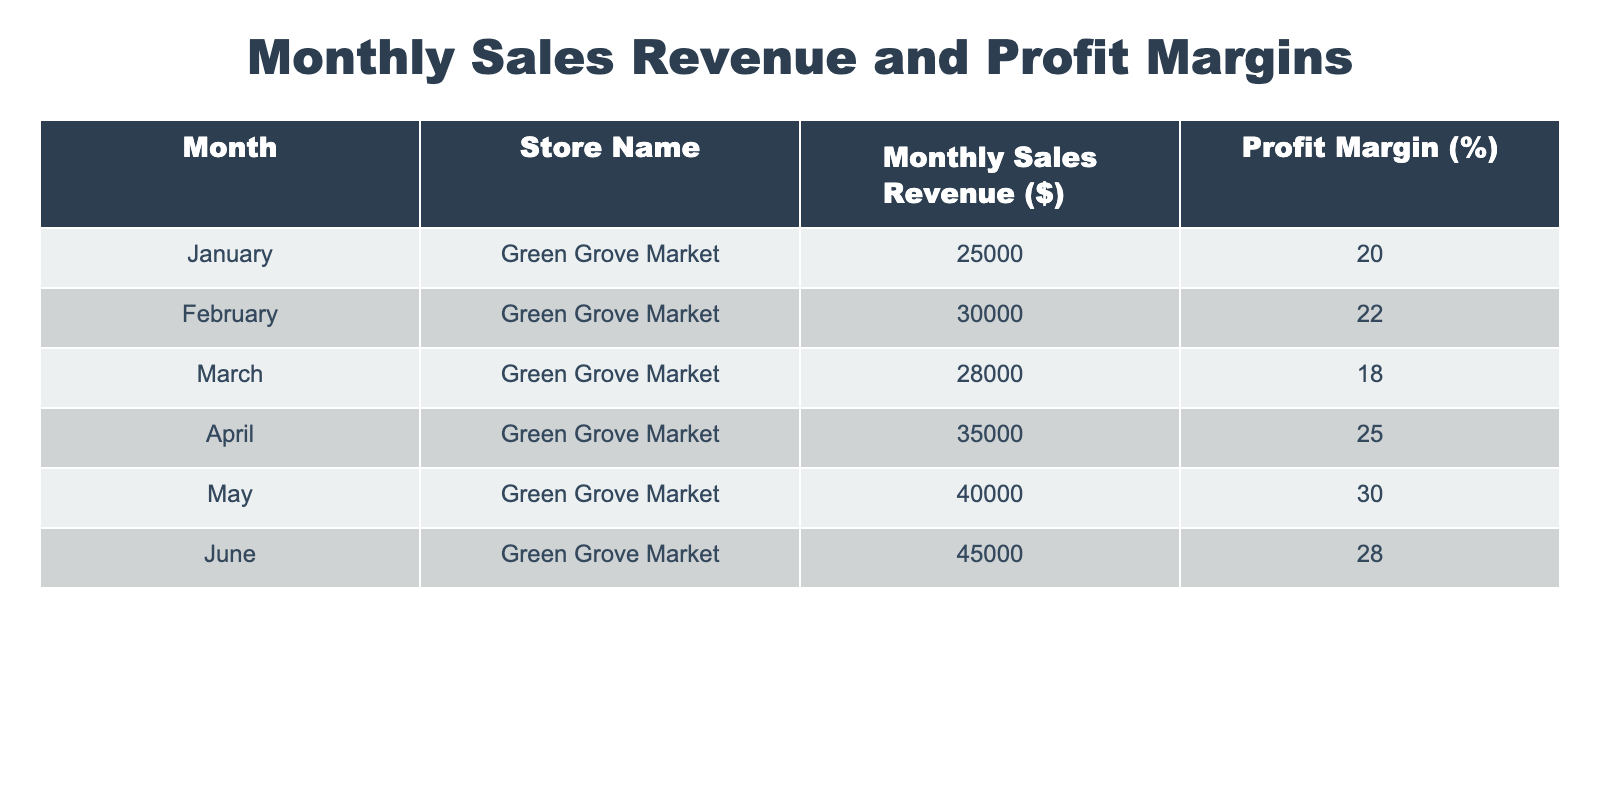What was the monthly sales revenue in June? The table directly lists the monthly sales revenue for each month. Specifically, for June, the value given in the table is 45000.
Answer: 45000 What is the profit margin in April? The table indicates that the profit margin for April is 25%. This is a straightforward retrieval from the table.
Answer: 25% Which month had the highest profit margin, and what was it? By examining the profit margins for each month listed in the table, April has the highest at 25%. This requires comparing the values.
Answer: April, 25% What is the average monthly sales revenue over the six months? To calculate the average monthly sales revenue, add all the monthly sales revenue values: 25000 + 30000 + 28000 + 35000 + 40000 + 45000 = 203000. Then, divide by the number of months (6): 203000/6 = approximately 33833.33.
Answer: 33833.33 Is the profit margin in May higher than in March? The table shows that the profit margin in May is 30% while in March it is 18%. Since 30% > 18%, the answer is yes. This requires a simple comparison.
Answer: Yes Which month showed the greatest increase in sales revenue compared to the previous month? By comparing the monthly sales revenues: January to February (30000 - 25000 = 5000), February to March (28000 - 30000 = -2000), March to April (35000 - 28000 = 7000), April to May (40000 - 35000 = 5000), and May to June (45000 - 40000 = 5000). The greatest increase is from March to April, a difference of 7000. This requires calculating the differences and finding the maximum.
Answer: March to April, 7000 How many months had a profit margin greater than 20%? The months with profit margins over 20% are February (22%), April (25%), and May (30%). Counting these gives us three months. This involves filtering the data based on the profit margin and counting those instances.
Answer: 3 Was the sales revenue in January more than in March? Comparing the sales revenue, January had 25000 and March had 28000. Since 25000 < 28000, the answer is no. This requires direct comparison of the values from the respective months.
Answer: No What is the total sales revenue over the six-month period? By summing the monthly sales revenue: 25000 + 30000 + 28000 + 35000 + 40000 + 45000 = 203000. This is a straightforward summation of all values in the sales revenue column.
Answer: 203000 